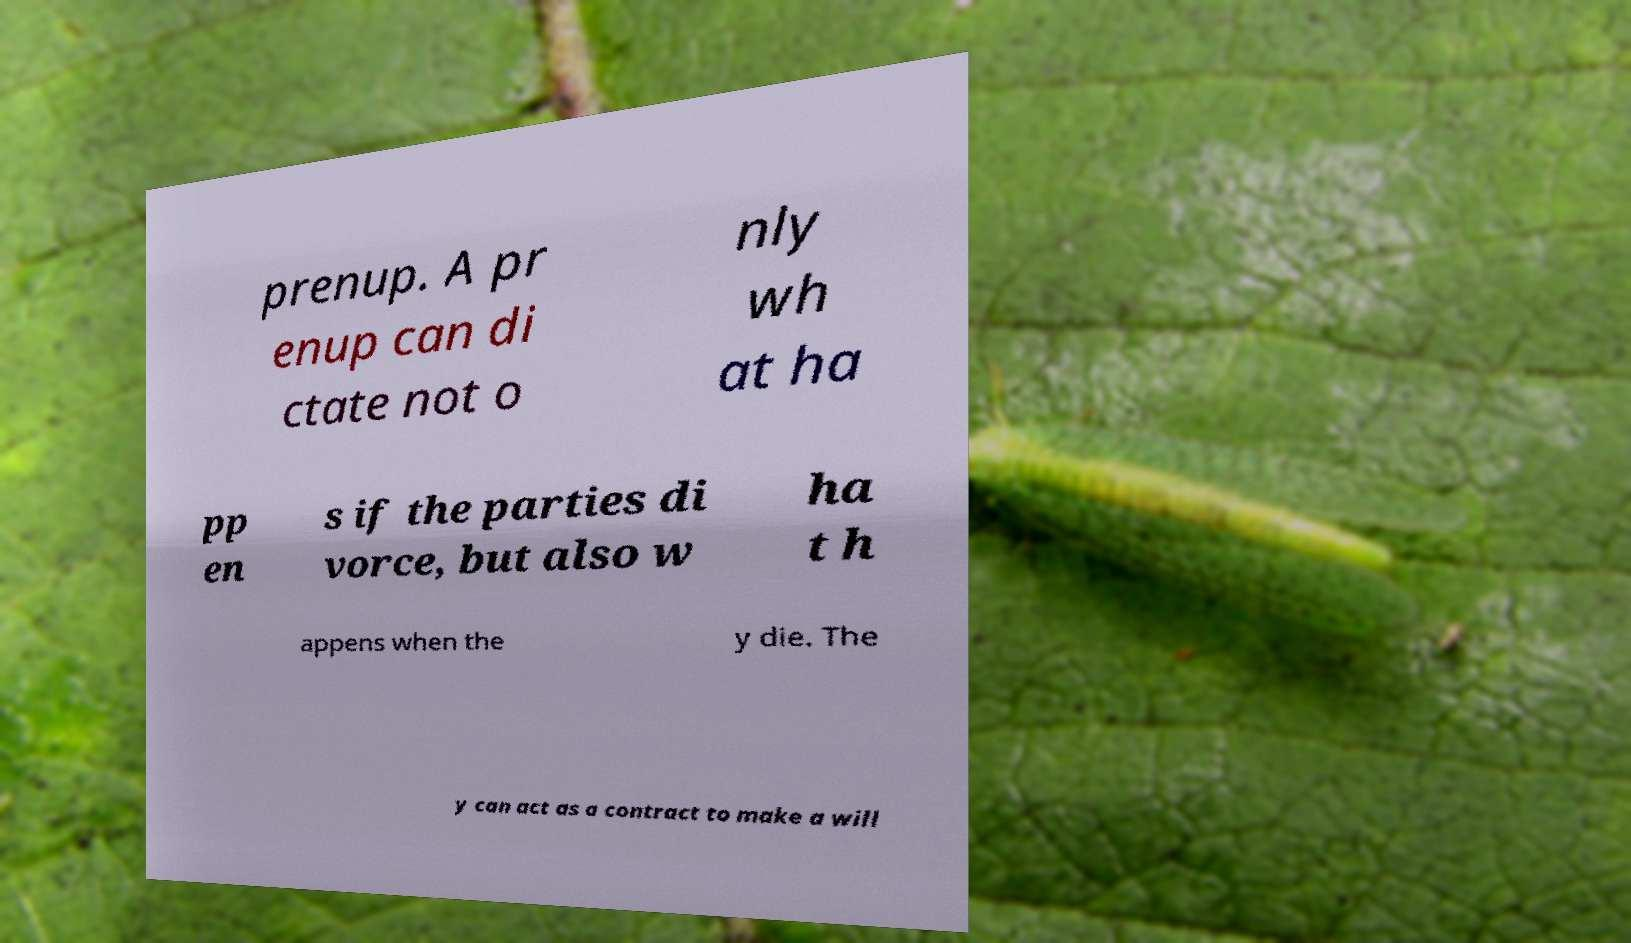What messages or text are displayed in this image? I need them in a readable, typed format. prenup. A pr enup can di ctate not o nly wh at ha pp en s if the parties di vorce, but also w ha t h appens when the y die. The y can act as a contract to make a will 